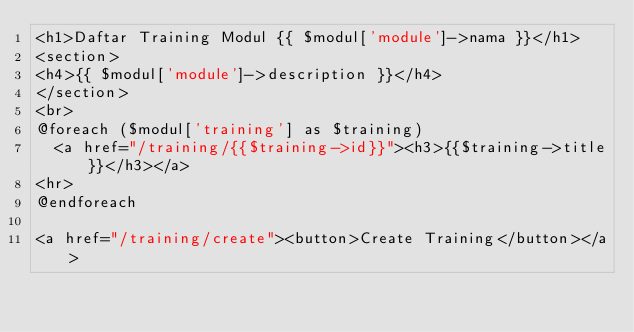Convert code to text. <code><loc_0><loc_0><loc_500><loc_500><_PHP_><h1>Daftar Training Modul {{ $modul['module']->nama }}</h1>
<section>
<h4>{{ $modul['module']->description }}</h4>
</section>
<br>
@foreach ($modul['training'] as $training)
  <a href="/training/{{$training->id}}"><h3>{{$training->title}}</h3></a>
<hr>
@endforeach

<a href="/training/create"><button>Create Training</button></a>

</code> 